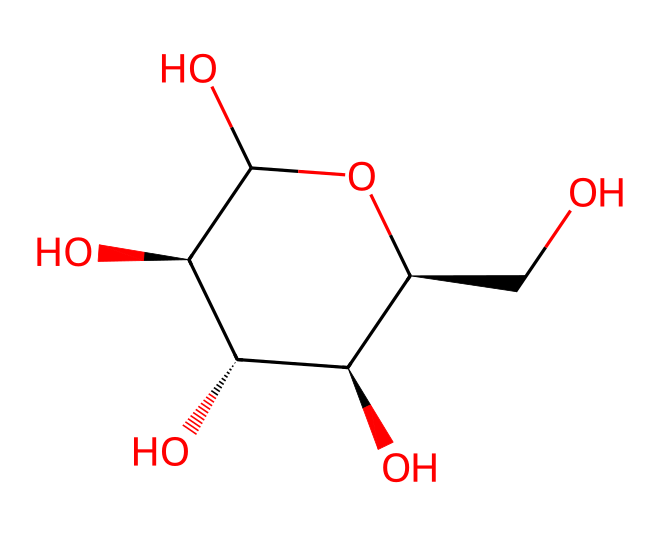What is the primary component of this chemical? This chemical represents amylose, which is a linear polymer made up of glucose units. The structure contains repeated glucose units connected by α-1,4-glycosidic bonds.
Answer: amylose How many carbon atoms are present in this molecule? By examining the structure, there are 6 carbon atoms present in the depicted glucose unit, and since there are multiple units in amylose, we can count the number of carbon atoms based on the total units. However, the focus here is on one glucose unit which is the primary structure seen.
Answer: 6 What type of glycosidic linkages are present in this structure? The structure shows that the glucose units are linked by α-1,4-glycosidic bonds, which are characteristic of amylose and contribute to its linear structure.
Answer: α-1,4-glycosidic How does the structure of amylose impact food texture compared to amylopectin? Amylose's linear structure allows it to form helical shapes, leading to a firmer texture in foods, while the branched structure of amylopectin makes it softer and creamier. The differing structural properties lead to distinct textural outcomes in food products.
Answer: firmer What is the molecular formula for the repeating unit in amylose? The repeating unit in amylose is a glucose molecule, which has the molecular formula C6H12O6. This is consistent throughout the structure as all units are glucose.
Answer: C6H12O6 